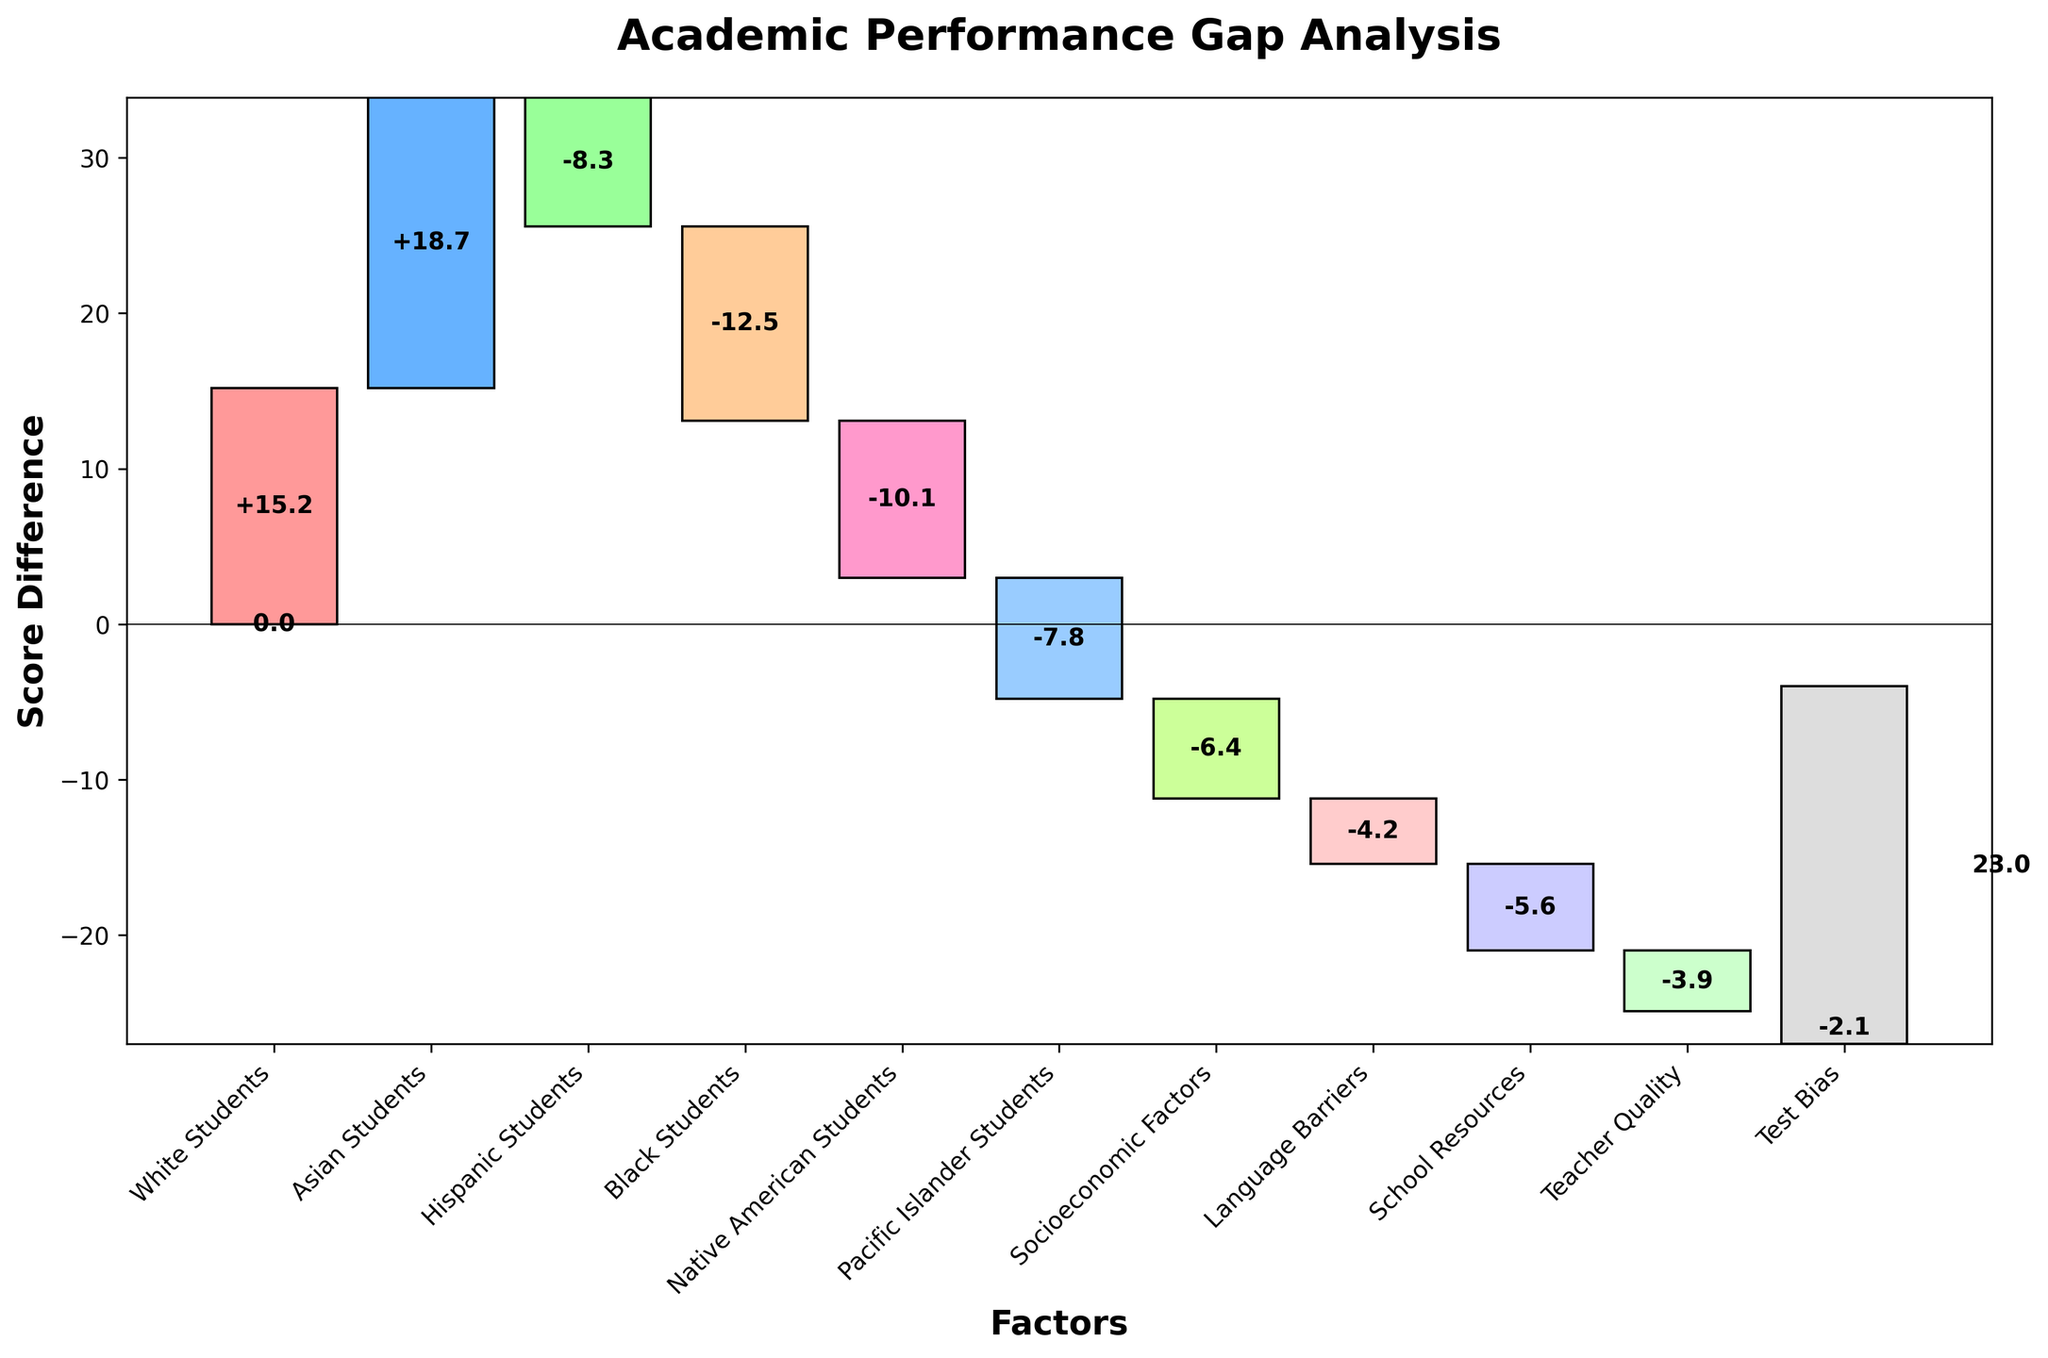What is the title of the Waterfall Chart? The chart's title is located at the top center of the figure and provides the main topic of the visualization.
Answer: Academic Performance Gap Analysis What does the 'Initial Score' represent in the Waterfall Chart? The 'Initial Score' is the starting point of the analysis, showing the baseline from which other changes are measured. It is represented by a gray bar at the beginning of the chart.
Answer: 0 How much does the 'Asian Students' category contribute to the performance gap? The contribution of 'Asian Students' is explicitly labeled on the chart. It is shown by a bar in the chart with a corresponding value.
Answer: +18.7 Which category has the largest negative impact on academic performance? By comparing the negative values among the categories, the one with the largest negative value indicates the largest negative impact.
Answer: Black Students (-12.5) What is the final academic performance gap shown in the chart? The final performance gap is given at the end of the waterfall chart and is displayed at the final cumulative sum bar label.
Answer: 23.0 Calculate the total positive contributions from different student groups on the chart. Add the positive contributions of 'White Students' (+15.2) and 'Asian Students' (+18.7).
Answer: 33.9 What's the difference in the impact between 'Hispanic Students' and 'Socioeconomic Factors'? Subtract the value of 'Socioeconomic Factors' (-6.4) from 'Hispanic Students' (-8.3).
Answer: -1.9 Which factor contributes less to the performance gap: 'Teacher Quality' or 'Test Bias'? Compare the values of 'Teacher Quality' (-3.9) and 'Test Bias' (-2.1). The one with a smaller absolute value contributes less.
Answer: Test Bias Describe the overall trend shown in the chart in terms of positive and negative contributions. The chart starts at an initial score of 0 with student groups having both positive and negative contributions, followed by several negative factors, and ends at a final gap of 23.0, indicating a net positive gap.
Answer: Mixed contributions with a net positive gap How do socioeconomic factors, language barriers, and school resources together affect the performance gap? Add the negative contributions: 'Socioeconomic Factors' (-6.4), 'Language Barriers' (-4.2), and 'School Resources' (-5.6).
Answer: -16.2 